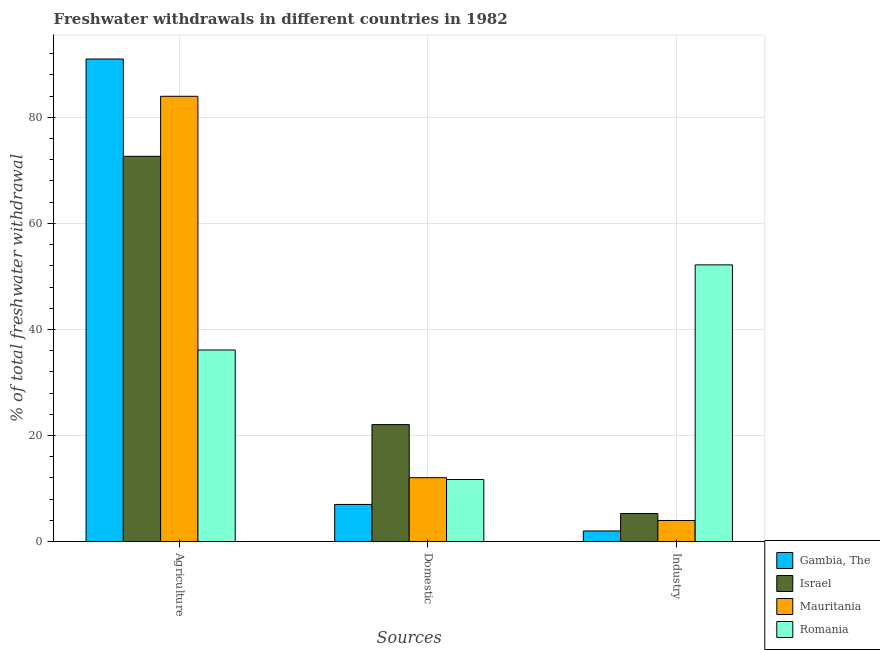How many different coloured bars are there?
Your response must be concise. 4. How many groups of bars are there?
Provide a short and direct response. 3. Are the number of bars per tick equal to the number of legend labels?
Ensure brevity in your answer.  Yes. Are the number of bars on each tick of the X-axis equal?
Provide a succinct answer. Yes. How many bars are there on the 2nd tick from the left?
Make the answer very short. 4. What is the label of the 3rd group of bars from the left?
Your response must be concise. Industry. What is the percentage of freshwater withdrawal for domestic purposes in Gambia, The?
Your answer should be very brief. 7. Across all countries, what is the maximum percentage of freshwater withdrawal for industry?
Provide a succinct answer. 52.18. Across all countries, what is the minimum percentage of freshwater withdrawal for industry?
Your answer should be compact. 2. In which country was the percentage of freshwater withdrawal for domestic purposes maximum?
Keep it short and to the point. Israel. In which country was the percentage of freshwater withdrawal for domestic purposes minimum?
Your response must be concise. Gambia, The. What is the total percentage of freshwater withdrawal for industry in the graph?
Offer a terse response. 63.45. What is the difference between the percentage of freshwater withdrawal for industry in Gambia, The and that in Romania?
Provide a succinct answer. -50.18. What is the difference between the percentage of freshwater withdrawal for domestic purposes in Gambia, The and the percentage of freshwater withdrawal for industry in Mauritania?
Your answer should be very brief. 3.03. What is the average percentage of freshwater withdrawal for industry per country?
Your answer should be compact. 15.86. What is the difference between the percentage of freshwater withdrawal for industry and percentage of freshwater withdrawal for domestic purposes in Gambia, The?
Your answer should be very brief. -5. In how many countries, is the percentage of freshwater withdrawal for agriculture greater than 76 %?
Your answer should be very brief. 2. What is the ratio of the percentage of freshwater withdrawal for agriculture in Gambia, The to that in Mauritania?
Make the answer very short. 1.08. What is the difference between the highest and the second highest percentage of freshwater withdrawal for domestic purposes?
Your response must be concise. 10.01. What is the difference between the highest and the lowest percentage of freshwater withdrawal for industry?
Provide a succinct answer. 50.18. In how many countries, is the percentage of freshwater withdrawal for agriculture greater than the average percentage of freshwater withdrawal for agriculture taken over all countries?
Ensure brevity in your answer.  3. Is the sum of the percentage of freshwater withdrawal for industry in Gambia, The and Mauritania greater than the maximum percentage of freshwater withdrawal for agriculture across all countries?
Make the answer very short. No. What does the 4th bar from the right in Agriculture represents?
Make the answer very short. Gambia, The. Is it the case that in every country, the sum of the percentage of freshwater withdrawal for agriculture and percentage of freshwater withdrawal for domestic purposes is greater than the percentage of freshwater withdrawal for industry?
Your response must be concise. No. How many bars are there?
Your answer should be very brief. 12. How many countries are there in the graph?
Provide a succinct answer. 4. What is the difference between two consecutive major ticks on the Y-axis?
Provide a succinct answer. 20. Does the graph contain any zero values?
Keep it short and to the point. No. Does the graph contain grids?
Your answer should be compact. Yes. How many legend labels are there?
Make the answer very short. 4. How are the legend labels stacked?
Keep it short and to the point. Vertical. What is the title of the graph?
Make the answer very short. Freshwater withdrawals in different countries in 1982. What is the label or title of the X-axis?
Ensure brevity in your answer.  Sources. What is the label or title of the Y-axis?
Your answer should be compact. % of total freshwater withdrawal. What is the % of total freshwater withdrawal of Gambia, The in Agriculture?
Give a very brief answer. 91. What is the % of total freshwater withdrawal of Israel in Agriculture?
Give a very brief answer. 72.65. What is the % of total freshwater withdrawal in Mauritania in Agriculture?
Keep it short and to the point. 83.97. What is the % of total freshwater withdrawal in Romania in Agriculture?
Make the answer very short. 36.12. What is the % of total freshwater withdrawal of Gambia, The in Domestic?
Provide a succinct answer. 7. What is the % of total freshwater withdrawal in Israel in Domestic?
Your answer should be very brief. 22.06. What is the % of total freshwater withdrawal in Mauritania in Domestic?
Keep it short and to the point. 12.05. What is the % of total freshwater withdrawal in Gambia, The in Industry?
Offer a terse response. 2. What is the % of total freshwater withdrawal of Israel in Industry?
Offer a terse response. 5.29. What is the % of total freshwater withdrawal of Mauritania in Industry?
Provide a succinct answer. 3.97. What is the % of total freshwater withdrawal of Romania in Industry?
Give a very brief answer. 52.18. Across all Sources, what is the maximum % of total freshwater withdrawal of Gambia, The?
Offer a terse response. 91. Across all Sources, what is the maximum % of total freshwater withdrawal of Israel?
Keep it short and to the point. 72.65. Across all Sources, what is the maximum % of total freshwater withdrawal in Mauritania?
Offer a very short reply. 83.97. Across all Sources, what is the maximum % of total freshwater withdrawal of Romania?
Your answer should be compact. 52.18. Across all Sources, what is the minimum % of total freshwater withdrawal in Israel?
Offer a terse response. 5.29. Across all Sources, what is the minimum % of total freshwater withdrawal in Mauritania?
Your response must be concise. 3.97. What is the total % of total freshwater withdrawal of Gambia, The in the graph?
Provide a succinct answer. 100. What is the total % of total freshwater withdrawal of Israel in the graph?
Your response must be concise. 100. What is the total % of total freshwater withdrawal of Mauritania in the graph?
Make the answer very short. 99.99. What is the difference between the % of total freshwater withdrawal in Israel in Agriculture and that in Domestic?
Provide a succinct answer. 50.59. What is the difference between the % of total freshwater withdrawal in Mauritania in Agriculture and that in Domestic?
Your response must be concise. 71.92. What is the difference between the % of total freshwater withdrawal in Romania in Agriculture and that in Domestic?
Your answer should be very brief. 24.42. What is the difference between the % of total freshwater withdrawal of Gambia, The in Agriculture and that in Industry?
Your answer should be very brief. 89. What is the difference between the % of total freshwater withdrawal in Israel in Agriculture and that in Industry?
Your response must be concise. 67.36. What is the difference between the % of total freshwater withdrawal in Mauritania in Agriculture and that in Industry?
Provide a short and direct response. 80. What is the difference between the % of total freshwater withdrawal of Romania in Agriculture and that in Industry?
Make the answer very short. -16.06. What is the difference between the % of total freshwater withdrawal in Israel in Domestic and that in Industry?
Your answer should be very brief. 16.77. What is the difference between the % of total freshwater withdrawal of Mauritania in Domestic and that in Industry?
Provide a short and direct response. 8.08. What is the difference between the % of total freshwater withdrawal of Romania in Domestic and that in Industry?
Keep it short and to the point. -40.48. What is the difference between the % of total freshwater withdrawal in Gambia, The in Agriculture and the % of total freshwater withdrawal in Israel in Domestic?
Provide a succinct answer. 68.94. What is the difference between the % of total freshwater withdrawal of Gambia, The in Agriculture and the % of total freshwater withdrawal of Mauritania in Domestic?
Give a very brief answer. 78.95. What is the difference between the % of total freshwater withdrawal in Gambia, The in Agriculture and the % of total freshwater withdrawal in Romania in Domestic?
Provide a succinct answer. 79.3. What is the difference between the % of total freshwater withdrawal in Israel in Agriculture and the % of total freshwater withdrawal in Mauritania in Domestic?
Offer a very short reply. 60.6. What is the difference between the % of total freshwater withdrawal of Israel in Agriculture and the % of total freshwater withdrawal of Romania in Domestic?
Give a very brief answer. 60.95. What is the difference between the % of total freshwater withdrawal in Mauritania in Agriculture and the % of total freshwater withdrawal in Romania in Domestic?
Your answer should be compact. 72.27. What is the difference between the % of total freshwater withdrawal in Gambia, The in Agriculture and the % of total freshwater withdrawal in Israel in Industry?
Provide a short and direct response. 85.71. What is the difference between the % of total freshwater withdrawal of Gambia, The in Agriculture and the % of total freshwater withdrawal of Mauritania in Industry?
Offer a terse response. 87.03. What is the difference between the % of total freshwater withdrawal of Gambia, The in Agriculture and the % of total freshwater withdrawal of Romania in Industry?
Make the answer very short. 38.82. What is the difference between the % of total freshwater withdrawal in Israel in Agriculture and the % of total freshwater withdrawal in Mauritania in Industry?
Offer a terse response. 68.68. What is the difference between the % of total freshwater withdrawal in Israel in Agriculture and the % of total freshwater withdrawal in Romania in Industry?
Your response must be concise. 20.47. What is the difference between the % of total freshwater withdrawal of Mauritania in Agriculture and the % of total freshwater withdrawal of Romania in Industry?
Provide a short and direct response. 31.79. What is the difference between the % of total freshwater withdrawal in Gambia, The in Domestic and the % of total freshwater withdrawal in Israel in Industry?
Your answer should be very brief. 1.71. What is the difference between the % of total freshwater withdrawal in Gambia, The in Domestic and the % of total freshwater withdrawal in Mauritania in Industry?
Your response must be concise. 3.03. What is the difference between the % of total freshwater withdrawal of Gambia, The in Domestic and the % of total freshwater withdrawal of Romania in Industry?
Provide a short and direct response. -45.18. What is the difference between the % of total freshwater withdrawal of Israel in Domestic and the % of total freshwater withdrawal of Mauritania in Industry?
Your answer should be compact. 18.09. What is the difference between the % of total freshwater withdrawal of Israel in Domestic and the % of total freshwater withdrawal of Romania in Industry?
Offer a terse response. -30.12. What is the difference between the % of total freshwater withdrawal of Mauritania in Domestic and the % of total freshwater withdrawal of Romania in Industry?
Give a very brief answer. -40.13. What is the average % of total freshwater withdrawal in Gambia, The per Sources?
Offer a terse response. 33.33. What is the average % of total freshwater withdrawal of Israel per Sources?
Offer a terse response. 33.33. What is the average % of total freshwater withdrawal of Mauritania per Sources?
Ensure brevity in your answer.  33.33. What is the average % of total freshwater withdrawal of Romania per Sources?
Provide a succinct answer. 33.33. What is the difference between the % of total freshwater withdrawal of Gambia, The and % of total freshwater withdrawal of Israel in Agriculture?
Provide a succinct answer. 18.35. What is the difference between the % of total freshwater withdrawal of Gambia, The and % of total freshwater withdrawal of Mauritania in Agriculture?
Your answer should be compact. 7.03. What is the difference between the % of total freshwater withdrawal in Gambia, The and % of total freshwater withdrawal in Romania in Agriculture?
Give a very brief answer. 54.88. What is the difference between the % of total freshwater withdrawal in Israel and % of total freshwater withdrawal in Mauritania in Agriculture?
Your answer should be very brief. -11.32. What is the difference between the % of total freshwater withdrawal in Israel and % of total freshwater withdrawal in Romania in Agriculture?
Your response must be concise. 36.53. What is the difference between the % of total freshwater withdrawal of Mauritania and % of total freshwater withdrawal of Romania in Agriculture?
Your answer should be compact. 47.85. What is the difference between the % of total freshwater withdrawal in Gambia, The and % of total freshwater withdrawal in Israel in Domestic?
Give a very brief answer. -15.06. What is the difference between the % of total freshwater withdrawal in Gambia, The and % of total freshwater withdrawal in Mauritania in Domestic?
Offer a very short reply. -5.05. What is the difference between the % of total freshwater withdrawal in Gambia, The and % of total freshwater withdrawal in Romania in Domestic?
Provide a succinct answer. -4.7. What is the difference between the % of total freshwater withdrawal in Israel and % of total freshwater withdrawal in Mauritania in Domestic?
Provide a short and direct response. 10.01. What is the difference between the % of total freshwater withdrawal in Israel and % of total freshwater withdrawal in Romania in Domestic?
Offer a very short reply. 10.36. What is the difference between the % of total freshwater withdrawal in Gambia, The and % of total freshwater withdrawal in Israel in Industry?
Provide a succinct answer. -3.29. What is the difference between the % of total freshwater withdrawal of Gambia, The and % of total freshwater withdrawal of Mauritania in Industry?
Your answer should be very brief. -1.97. What is the difference between the % of total freshwater withdrawal in Gambia, The and % of total freshwater withdrawal in Romania in Industry?
Give a very brief answer. -50.18. What is the difference between the % of total freshwater withdrawal in Israel and % of total freshwater withdrawal in Mauritania in Industry?
Make the answer very short. 1.32. What is the difference between the % of total freshwater withdrawal of Israel and % of total freshwater withdrawal of Romania in Industry?
Provide a succinct answer. -46.89. What is the difference between the % of total freshwater withdrawal in Mauritania and % of total freshwater withdrawal in Romania in Industry?
Provide a short and direct response. -48.21. What is the ratio of the % of total freshwater withdrawal of Gambia, The in Agriculture to that in Domestic?
Your answer should be compact. 13. What is the ratio of the % of total freshwater withdrawal in Israel in Agriculture to that in Domestic?
Your answer should be very brief. 3.29. What is the ratio of the % of total freshwater withdrawal of Mauritania in Agriculture to that in Domestic?
Keep it short and to the point. 6.97. What is the ratio of the % of total freshwater withdrawal of Romania in Agriculture to that in Domestic?
Your response must be concise. 3.09. What is the ratio of the % of total freshwater withdrawal of Gambia, The in Agriculture to that in Industry?
Offer a very short reply. 45.5. What is the ratio of the % of total freshwater withdrawal of Israel in Agriculture to that in Industry?
Your response must be concise. 13.72. What is the ratio of the % of total freshwater withdrawal in Mauritania in Agriculture to that in Industry?
Your response must be concise. 21.14. What is the ratio of the % of total freshwater withdrawal of Romania in Agriculture to that in Industry?
Your answer should be compact. 0.69. What is the ratio of the % of total freshwater withdrawal in Gambia, The in Domestic to that in Industry?
Your answer should be compact. 3.5. What is the ratio of the % of total freshwater withdrawal in Israel in Domestic to that in Industry?
Offer a very short reply. 4.17. What is the ratio of the % of total freshwater withdrawal in Mauritania in Domestic to that in Industry?
Ensure brevity in your answer.  3.03. What is the ratio of the % of total freshwater withdrawal of Romania in Domestic to that in Industry?
Keep it short and to the point. 0.22. What is the difference between the highest and the second highest % of total freshwater withdrawal of Israel?
Your response must be concise. 50.59. What is the difference between the highest and the second highest % of total freshwater withdrawal of Mauritania?
Ensure brevity in your answer.  71.92. What is the difference between the highest and the second highest % of total freshwater withdrawal in Romania?
Provide a succinct answer. 16.06. What is the difference between the highest and the lowest % of total freshwater withdrawal of Gambia, The?
Provide a succinct answer. 89. What is the difference between the highest and the lowest % of total freshwater withdrawal of Israel?
Offer a very short reply. 67.36. What is the difference between the highest and the lowest % of total freshwater withdrawal of Mauritania?
Provide a short and direct response. 80. What is the difference between the highest and the lowest % of total freshwater withdrawal of Romania?
Your answer should be very brief. 40.48. 